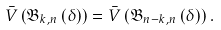<formula> <loc_0><loc_0><loc_500><loc_500>\bar { V } \left ( { { \mathfrak { B } _ { k , n } } \left ( \delta \right ) } \right ) = \bar { V } \left ( { { \mathfrak { B } _ { n - k , n } } \left ( \delta \right ) } \right ) .</formula> 